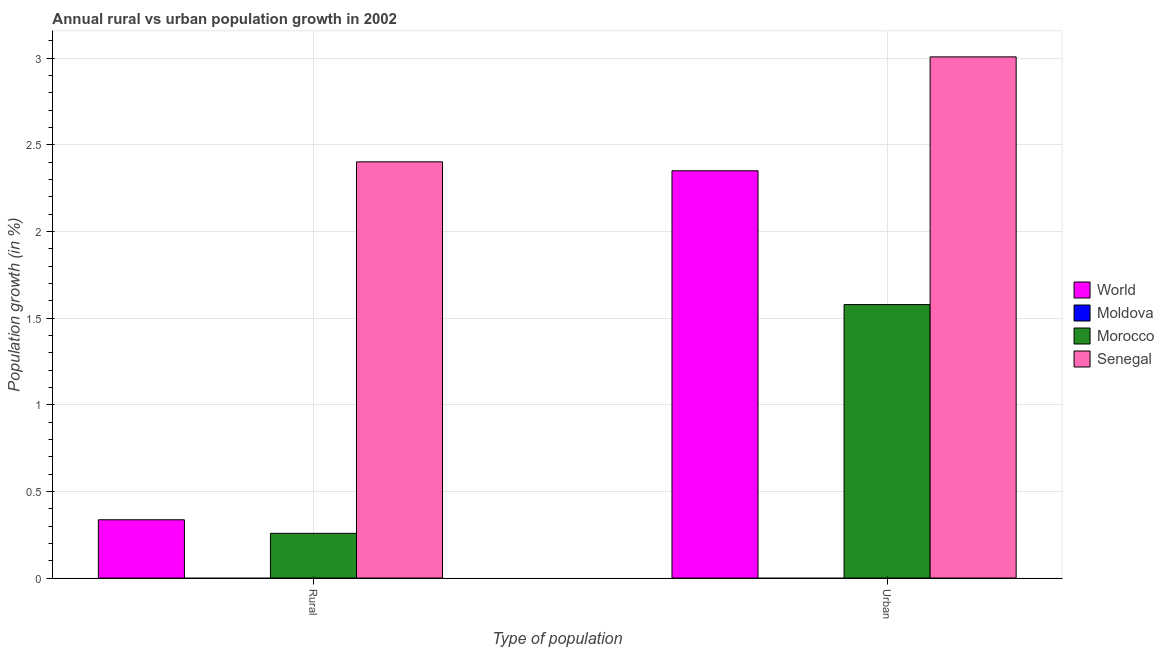Are the number of bars per tick equal to the number of legend labels?
Your answer should be compact. No. How many bars are there on the 2nd tick from the right?
Make the answer very short. 3. What is the label of the 2nd group of bars from the left?
Offer a terse response. Urban . What is the urban population growth in Morocco?
Your response must be concise. 1.58. Across all countries, what is the maximum rural population growth?
Your answer should be compact. 2.4. Across all countries, what is the minimum urban population growth?
Offer a very short reply. 0. In which country was the rural population growth maximum?
Offer a terse response. Senegal. What is the total urban population growth in the graph?
Your answer should be compact. 6.93. What is the difference between the rural population growth in Senegal and that in Morocco?
Offer a terse response. 2.14. What is the difference between the urban population growth in Senegal and the rural population growth in Morocco?
Offer a terse response. 2.75. What is the average rural population growth per country?
Offer a very short reply. 0.75. What is the difference between the rural population growth and urban population growth in Senegal?
Your response must be concise. -0.61. What is the ratio of the rural population growth in World to that in Morocco?
Offer a very short reply. 1.3. Is the rural population growth in Senegal less than that in World?
Provide a short and direct response. No. In how many countries, is the urban population growth greater than the average urban population growth taken over all countries?
Make the answer very short. 2. Are all the bars in the graph horizontal?
Your answer should be very brief. No. How many countries are there in the graph?
Keep it short and to the point. 4. Does the graph contain any zero values?
Keep it short and to the point. Yes. Does the graph contain grids?
Provide a short and direct response. Yes. Where does the legend appear in the graph?
Keep it short and to the point. Center right. How many legend labels are there?
Ensure brevity in your answer.  4. What is the title of the graph?
Ensure brevity in your answer.  Annual rural vs urban population growth in 2002. What is the label or title of the X-axis?
Offer a very short reply. Type of population. What is the label or title of the Y-axis?
Make the answer very short. Population growth (in %). What is the Population growth (in %) of World in Rural?
Your answer should be very brief. 0.34. What is the Population growth (in %) of Moldova in Rural?
Provide a succinct answer. 0. What is the Population growth (in %) of Morocco in Rural?
Ensure brevity in your answer.  0.26. What is the Population growth (in %) in Senegal in Rural?
Give a very brief answer. 2.4. What is the Population growth (in %) in World in Urban ?
Give a very brief answer. 2.35. What is the Population growth (in %) in Morocco in Urban ?
Keep it short and to the point. 1.58. What is the Population growth (in %) of Senegal in Urban ?
Offer a terse response. 3.01. Across all Type of population, what is the maximum Population growth (in %) of World?
Ensure brevity in your answer.  2.35. Across all Type of population, what is the maximum Population growth (in %) in Morocco?
Make the answer very short. 1.58. Across all Type of population, what is the maximum Population growth (in %) of Senegal?
Ensure brevity in your answer.  3.01. Across all Type of population, what is the minimum Population growth (in %) of World?
Ensure brevity in your answer.  0.34. Across all Type of population, what is the minimum Population growth (in %) in Morocco?
Provide a succinct answer. 0.26. Across all Type of population, what is the minimum Population growth (in %) in Senegal?
Keep it short and to the point. 2.4. What is the total Population growth (in %) in World in the graph?
Provide a succinct answer. 2.69. What is the total Population growth (in %) of Morocco in the graph?
Your response must be concise. 1.84. What is the total Population growth (in %) of Senegal in the graph?
Offer a terse response. 5.41. What is the difference between the Population growth (in %) in World in Rural and that in Urban ?
Ensure brevity in your answer.  -2.01. What is the difference between the Population growth (in %) in Morocco in Rural and that in Urban ?
Your response must be concise. -1.32. What is the difference between the Population growth (in %) of Senegal in Rural and that in Urban ?
Provide a short and direct response. -0.61. What is the difference between the Population growth (in %) of World in Rural and the Population growth (in %) of Morocco in Urban?
Give a very brief answer. -1.24. What is the difference between the Population growth (in %) of World in Rural and the Population growth (in %) of Senegal in Urban?
Ensure brevity in your answer.  -2.67. What is the difference between the Population growth (in %) in Morocco in Rural and the Population growth (in %) in Senegal in Urban?
Your answer should be very brief. -2.75. What is the average Population growth (in %) of World per Type of population?
Provide a succinct answer. 1.34. What is the average Population growth (in %) in Morocco per Type of population?
Give a very brief answer. 0.92. What is the average Population growth (in %) of Senegal per Type of population?
Make the answer very short. 2.7. What is the difference between the Population growth (in %) in World and Population growth (in %) in Morocco in Rural?
Keep it short and to the point. 0.08. What is the difference between the Population growth (in %) of World and Population growth (in %) of Senegal in Rural?
Make the answer very short. -2.06. What is the difference between the Population growth (in %) of Morocco and Population growth (in %) of Senegal in Rural?
Keep it short and to the point. -2.14. What is the difference between the Population growth (in %) in World and Population growth (in %) in Morocco in Urban ?
Offer a very short reply. 0.77. What is the difference between the Population growth (in %) of World and Population growth (in %) of Senegal in Urban ?
Offer a terse response. -0.66. What is the difference between the Population growth (in %) in Morocco and Population growth (in %) in Senegal in Urban ?
Your answer should be very brief. -1.43. What is the ratio of the Population growth (in %) in World in Rural to that in Urban ?
Make the answer very short. 0.14. What is the ratio of the Population growth (in %) in Morocco in Rural to that in Urban ?
Make the answer very short. 0.16. What is the ratio of the Population growth (in %) of Senegal in Rural to that in Urban ?
Your answer should be compact. 0.8. What is the difference between the highest and the second highest Population growth (in %) in World?
Your answer should be compact. 2.01. What is the difference between the highest and the second highest Population growth (in %) in Morocco?
Your answer should be very brief. 1.32. What is the difference between the highest and the second highest Population growth (in %) of Senegal?
Your answer should be very brief. 0.61. What is the difference between the highest and the lowest Population growth (in %) of World?
Your answer should be very brief. 2.01. What is the difference between the highest and the lowest Population growth (in %) of Morocco?
Offer a very short reply. 1.32. What is the difference between the highest and the lowest Population growth (in %) of Senegal?
Your answer should be very brief. 0.61. 